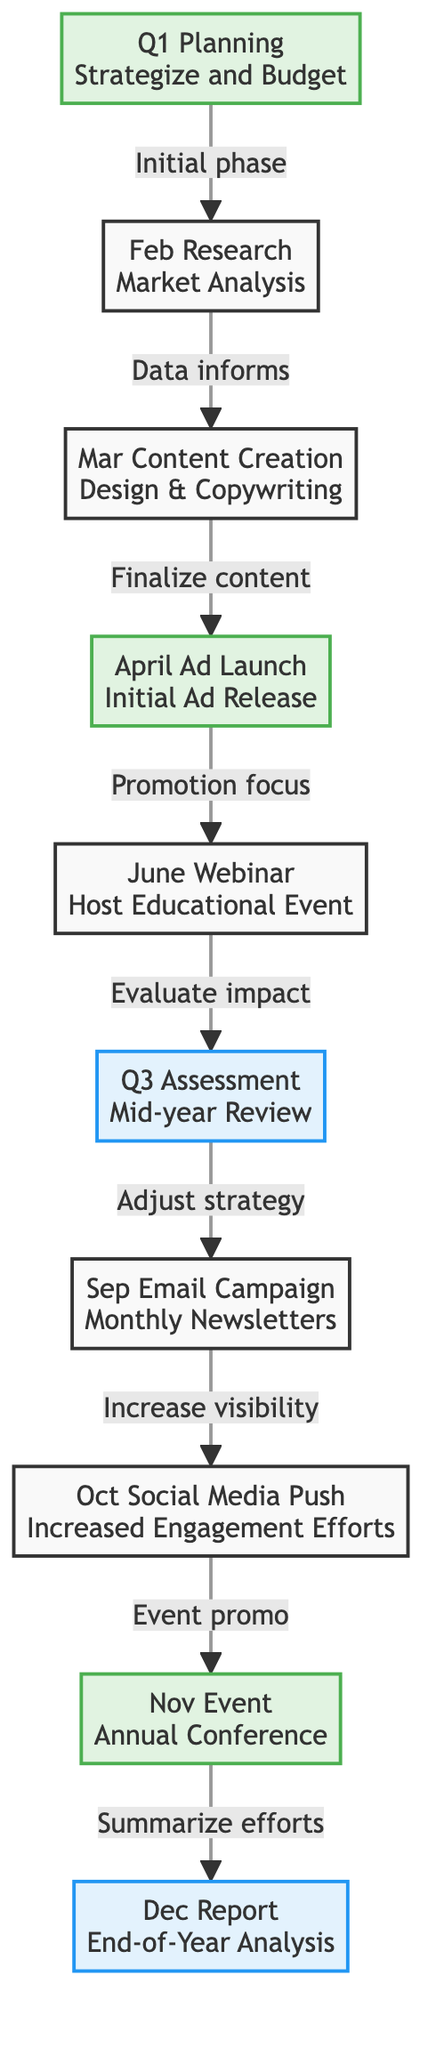What is the milestone in April? The April milestone is identified as "April Ad Launch," which is a key event in the marketing campaign timeline.
Answer: April Ad Launch What is the last assessment listed in the timeline? The last assessment is "Dec Report," which is focused on end-of-year analysis. It comes after the annual conference in November.
Answer: Dec Report How many milestones are there in total? There are five milestones identified within the diagram: Q1 Planning, April Ad Launch, June Webinar, Nov Event, and Dec Report.
Answer: 5 What follows the June Webinar in the workflow? After the June Webinar, the next step is the Q3 Assessment, which evaluates the impact of the webinar and previous activities.
Answer: Q3 Assessment Which activity is directly linked to the Q3 Assessment? The activity directly linked to the Q3 Assessment is "Sep Email Campaign," indicating an adjustment to the campaign strategy based on the assessment results.
Answer: Sep Email Campaign What connects the Mar Content Creation and April Ad Launch? The connection indicates that the content created in March must be finalized before the April Ad Launch can occur.
Answer: Finalize content Which month does the Event occur? The Event is scheduled for November, as shown in the milestone list within the diagram.
Answer: November How does the October Social Media Push relate to the prior activity? The October Social Media Push is linked to increasing visibility for the upcoming November Event, indicating it serves as promotional support.
Answer: Increase visibility What is emphasized in Q3 Assessment? Q3 Assessment emphasizes conducting a mid-year review to evaluate strategies and progress.
Answer: Mid-year Review 